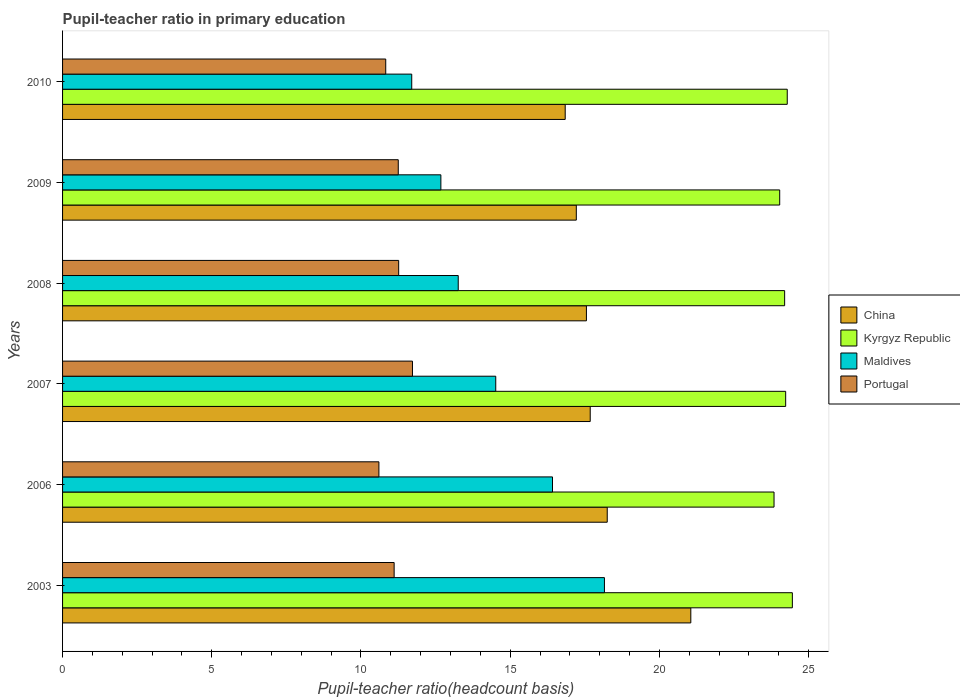How many different coloured bars are there?
Make the answer very short. 4. How many groups of bars are there?
Make the answer very short. 6. Are the number of bars on each tick of the Y-axis equal?
Make the answer very short. Yes. How many bars are there on the 4th tick from the top?
Your answer should be very brief. 4. What is the label of the 1st group of bars from the top?
Offer a terse response. 2010. In how many cases, is the number of bars for a given year not equal to the number of legend labels?
Your response must be concise. 0. What is the pupil-teacher ratio in primary education in Maldives in 2009?
Ensure brevity in your answer.  12.68. Across all years, what is the maximum pupil-teacher ratio in primary education in Portugal?
Provide a succinct answer. 11.73. Across all years, what is the minimum pupil-teacher ratio in primary education in Maldives?
Your answer should be compact. 11.7. In which year was the pupil-teacher ratio in primary education in China maximum?
Provide a short and direct response. 2003. What is the total pupil-teacher ratio in primary education in Kyrgyz Republic in the graph?
Offer a terse response. 145.04. What is the difference between the pupil-teacher ratio in primary education in China in 2006 and that in 2008?
Your answer should be compact. 0.7. What is the difference between the pupil-teacher ratio in primary education in Kyrgyz Republic in 2009 and the pupil-teacher ratio in primary education in China in 2007?
Offer a terse response. 6.35. What is the average pupil-teacher ratio in primary education in Portugal per year?
Your response must be concise. 11.13. In the year 2003, what is the difference between the pupil-teacher ratio in primary education in China and pupil-teacher ratio in primary education in Maldives?
Make the answer very short. 2.89. In how many years, is the pupil-teacher ratio in primary education in Maldives greater than 14 ?
Your answer should be compact. 3. What is the ratio of the pupil-teacher ratio in primary education in Kyrgyz Republic in 2009 to that in 2010?
Your response must be concise. 0.99. Is the pupil-teacher ratio in primary education in China in 2009 less than that in 2010?
Your answer should be very brief. No. What is the difference between the highest and the second highest pupil-teacher ratio in primary education in China?
Provide a succinct answer. 2.8. What is the difference between the highest and the lowest pupil-teacher ratio in primary education in Portugal?
Offer a very short reply. 1.12. Is the sum of the pupil-teacher ratio in primary education in China in 2006 and 2010 greater than the maximum pupil-teacher ratio in primary education in Kyrgyz Republic across all years?
Your answer should be compact. Yes. Is it the case that in every year, the sum of the pupil-teacher ratio in primary education in Portugal and pupil-teacher ratio in primary education in Maldives is greater than the sum of pupil-teacher ratio in primary education in Kyrgyz Republic and pupil-teacher ratio in primary education in China?
Keep it short and to the point. No. What does the 4th bar from the top in 2003 represents?
Give a very brief answer. China. What does the 2nd bar from the bottom in 2007 represents?
Offer a terse response. Kyrgyz Republic. Is it the case that in every year, the sum of the pupil-teacher ratio in primary education in Portugal and pupil-teacher ratio in primary education in Kyrgyz Republic is greater than the pupil-teacher ratio in primary education in Maldives?
Offer a very short reply. Yes. How are the legend labels stacked?
Your answer should be compact. Vertical. What is the title of the graph?
Offer a very short reply. Pupil-teacher ratio in primary education. What is the label or title of the X-axis?
Offer a terse response. Pupil-teacher ratio(headcount basis). What is the Pupil-teacher ratio(headcount basis) in China in 2003?
Provide a succinct answer. 21.05. What is the Pupil-teacher ratio(headcount basis) in Kyrgyz Republic in 2003?
Provide a succinct answer. 24.46. What is the Pupil-teacher ratio(headcount basis) of Maldives in 2003?
Your answer should be compact. 18.16. What is the Pupil-teacher ratio(headcount basis) in Portugal in 2003?
Your answer should be very brief. 11.11. What is the Pupil-teacher ratio(headcount basis) of China in 2006?
Your answer should be very brief. 18.25. What is the Pupil-teacher ratio(headcount basis) of Kyrgyz Republic in 2006?
Keep it short and to the point. 23.84. What is the Pupil-teacher ratio(headcount basis) in Maldives in 2006?
Your response must be concise. 16.42. What is the Pupil-teacher ratio(headcount basis) of Portugal in 2006?
Offer a very short reply. 10.6. What is the Pupil-teacher ratio(headcount basis) of China in 2007?
Your response must be concise. 17.68. What is the Pupil-teacher ratio(headcount basis) in Kyrgyz Republic in 2007?
Keep it short and to the point. 24.23. What is the Pupil-teacher ratio(headcount basis) of Maldives in 2007?
Your answer should be compact. 14.52. What is the Pupil-teacher ratio(headcount basis) of Portugal in 2007?
Offer a very short reply. 11.73. What is the Pupil-teacher ratio(headcount basis) of China in 2008?
Offer a very short reply. 17.55. What is the Pupil-teacher ratio(headcount basis) in Kyrgyz Republic in 2008?
Provide a short and direct response. 24.2. What is the Pupil-teacher ratio(headcount basis) of Maldives in 2008?
Your answer should be compact. 13.26. What is the Pupil-teacher ratio(headcount basis) in Portugal in 2008?
Keep it short and to the point. 11.26. What is the Pupil-teacher ratio(headcount basis) in China in 2009?
Keep it short and to the point. 17.22. What is the Pupil-teacher ratio(headcount basis) of Kyrgyz Republic in 2009?
Make the answer very short. 24.03. What is the Pupil-teacher ratio(headcount basis) of Maldives in 2009?
Ensure brevity in your answer.  12.68. What is the Pupil-teacher ratio(headcount basis) in Portugal in 2009?
Offer a very short reply. 11.25. What is the Pupil-teacher ratio(headcount basis) in China in 2010?
Your response must be concise. 16.84. What is the Pupil-teacher ratio(headcount basis) in Kyrgyz Republic in 2010?
Provide a short and direct response. 24.28. What is the Pupil-teacher ratio(headcount basis) of Maldives in 2010?
Your response must be concise. 11.7. What is the Pupil-teacher ratio(headcount basis) in Portugal in 2010?
Offer a terse response. 10.83. Across all years, what is the maximum Pupil-teacher ratio(headcount basis) of China?
Provide a short and direct response. 21.05. Across all years, what is the maximum Pupil-teacher ratio(headcount basis) of Kyrgyz Republic?
Keep it short and to the point. 24.46. Across all years, what is the maximum Pupil-teacher ratio(headcount basis) of Maldives?
Your response must be concise. 18.16. Across all years, what is the maximum Pupil-teacher ratio(headcount basis) in Portugal?
Your answer should be compact. 11.73. Across all years, what is the minimum Pupil-teacher ratio(headcount basis) of China?
Keep it short and to the point. 16.84. Across all years, what is the minimum Pupil-teacher ratio(headcount basis) of Kyrgyz Republic?
Provide a succinct answer. 23.84. Across all years, what is the minimum Pupil-teacher ratio(headcount basis) in Maldives?
Make the answer very short. 11.7. Across all years, what is the minimum Pupil-teacher ratio(headcount basis) in Portugal?
Provide a short and direct response. 10.6. What is the total Pupil-teacher ratio(headcount basis) in China in the graph?
Offer a very short reply. 108.6. What is the total Pupil-teacher ratio(headcount basis) in Kyrgyz Republic in the graph?
Make the answer very short. 145.04. What is the total Pupil-teacher ratio(headcount basis) of Maldives in the graph?
Offer a terse response. 86.73. What is the total Pupil-teacher ratio(headcount basis) of Portugal in the graph?
Your answer should be very brief. 66.78. What is the difference between the Pupil-teacher ratio(headcount basis) of China in 2003 and that in 2006?
Your answer should be very brief. 2.8. What is the difference between the Pupil-teacher ratio(headcount basis) in Kyrgyz Republic in 2003 and that in 2006?
Your answer should be very brief. 0.61. What is the difference between the Pupil-teacher ratio(headcount basis) of Maldives in 2003 and that in 2006?
Make the answer very short. 1.74. What is the difference between the Pupil-teacher ratio(headcount basis) in Portugal in 2003 and that in 2006?
Make the answer very short. 0.51. What is the difference between the Pupil-teacher ratio(headcount basis) in China in 2003 and that in 2007?
Keep it short and to the point. 3.37. What is the difference between the Pupil-teacher ratio(headcount basis) of Kyrgyz Republic in 2003 and that in 2007?
Provide a succinct answer. 0.22. What is the difference between the Pupil-teacher ratio(headcount basis) in Maldives in 2003 and that in 2007?
Offer a very short reply. 3.64. What is the difference between the Pupil-teacher ratio(headcount basis) in Portugal in 2003 and that in 2007?
Make the answer very short. -0.61. What is the difference between the Pupil-teacher ratio(headcount basis) of China in 2003 and that in 2008?
Your answer should be compact. 3.5. What is the difference between the Pupil-teacher ratio(headcount basis) of Kyrgyz Republic in 2003 and that in 2008?
Provide a succinct answer. 0.26. What is the difference between the Pupil-teacher ratio(headcount basis) of Maldives in 2003 and that in 2008?
Your response must be concise. 4.9. What is the difference between the Pupil-teacher ratio(headcount basis) of Portugal in 2003 and that in 2008?
Give a very brief answer. -0.15. What is the difference between the Pupil-teacher ratio(headcount basis) in China in 2003 and that in 2009?
Your answer should be very brief. 3.84. What is the difference between the Pupil-teacher ratio(headcount basis) in Kyrgyz Republic in 2003 and that in 2009?
Your answer should be compact. 0.42. What is the difference between the Pupil-teacher ratio(headcount basis) of Maldives in 2003 and that in 2009?
Provide a succinct answer. 5.48. What is the difference between the Pupil-teacher ratio(headcount basis) in Portugal in 2003 and that in 2009?
Give a very brief answer. -0.14. What is the difference between the Pupil-teacher ratio(headcount basis) of China in 2003 and that in 2010?
Your answer should be compact. 4.21. What is the difference between the Pupil-teacher ratio(headcount basis) of Kyrgyz Republic in 2003 and that in 2010?
Your answer should be very brief. 0.17. What is the difference between the Pupil-teacher ratio(headcount basis) in Maldives in 2003 and that in 2010?
Ensure brevity in your answer.  6.46. What is the difference between the Pupil-teacher ratio(headcount basis) of Portugal in 2003 and that in 2010?
Give a very brief answer. 0.28. What is the difference between the Pupil-teacher ratio(headcount basis) of China in 2006 and that in 2007?
Offer a very short reply. 0.57. What is the difference between the Pupil-teacher ratio(headcount basis) in Kyrgyz Republic in 2006 and that in 2007?
Give a very brief answer. -0.39. What is the difference between the Pupil-teacher ratio(headcount basis) in Maldives in 2006 and that in 2007?
Provide a short and direct response. 1.9. What is the difference between the Pupil-teacher ratio(headcount basis) of Portugal in 2006 and that in 2007?
Your answer should be compact. -1.12. What is the difference between the Pupil-teacher ratio(headcount basis) of China in 2006 and that in 2008?
Offer a very short reply. 0.7. What is the difference between the Pupil-teacher ratio(headcount basis) in Kyrgyz Republic in 2006 and that in 2008?
Offer a terse response. -0.36. What is the difference between the Pupil-teacher ratio(headcount basis) in Maldives in 2006 and that in 2008?
Your response must be concise. 3.16. What is the difference between the Pupil-teacher ratio(headcount basis) of Portugal in 2006 and that in 2008?
Ensure brevity in your answer.  -0.66. What is the difference between the Pupil-teacher ratio(headcount basis) of China in 2006 and that in 2009?
Your answer should be compact. 1.04. What is the difference between the Pupil-teacher ratio(headcount basis) of Kyrgyz Republic in 2006 and that in 2009?
Provide a succinct answer. -0.19. What is the difference between the Pupil-teacher ratio(headcount basis) of Maldives in 2006 and that in 2009?
Give a very brief answer. 3.74. What is the difference between the Pupil-teacher ratio(headcount basis) of Portugal in 2006 and that in 2009?
Offer a terse response. -0.65. What is the difference between the Pupil-teacher ratio(headcount basis) in China in 2006 and that in 2010?
Your response must be concise. 1.41. What is the difference between the Pupil-teacher ratio(headcount basis) in Kyrgyz Republic in 2006 and that in 2010?
Keep it short and to the point. -0.44. What is the difference between the Pupil-teacher ratio(headcount basis) of Maldives in 2006 and that in 2010?
Offer a terse response. 4.72. What is the difference between the Pupil-teacher ratio(headcount basis) in Portugal in 2006 and that in 2010?
Your response must be concise. -0.23. What is the difference between the Pupil-teacher ratio(headcount basis) in China in 2007 and that in 2008?
Keep it short and to the point. 0.13. What is the difference between the Pupil-teacher ratio(headcount basis) in Kyrgyz Republic in 2007 and that in 2008?
Your answer should be compact. 0.03. What is the difference between the Pupil-teacher ratio(headcount basis) in Maldives in 2007 and that in 2008?
Provide a short and direct response. 1.26. What is the difference between the Pupil-teacher ratio(headcount basis) in Portugal in 2007 and that in 2008?
Make the answer very short. 0.46. What is the difference between the Pupil-teacher ratio(headcount basis) of China in 2007 and that in 2009?
Your response must be concise. 0.47. What is the difference between the Pupil-teacher ratio(headcount basis) in Kyrgyz Republic in 2007 and that in 2009?
Your answer should be compact. 0.2. What is the difference between the Pupil-teacher ratio(headcount basis) in Maldives in 2007 and that in 2009?
Your answer should be very brief. 1.84. What is the difference between the Pupil-teacher ratio(headcount basis) in Portugal in 2007 and that in 2009?
Keep it short and to the point. 0.48. What is the difference between the Pupil-teacher ratio(headcount basis) in China in 2007 and that in 2010?
Provide a short and direct response. 0.84. What is the difference between the Pupil-teacher ratio(headcount basis) in Kyrgyz Republic in 2007 and that in 2010?
Keep it short and to the point. -0.05. What is the difference between the Pupil-teacher ratio(headcount basis) in Maldives in 2007 and that in 2010?
Provide a short and direct response. 2.82. What is the difference between the Pupil-teacher ratio(headcount basis) of Portugal in 2007 and that in 2010?
Ensure brevity in your answer.  0.9. What is the difference between the Pupil-teacher ratio(headcount basis) in China in 2008 and that in 2009?
Ensure brevity in your answer.  0.34. What is the difference between the Pupil-teacher ratio(headcount basis) in Kyrgyz Republic in 2008 and that in 2009?
Provide a succinct answer. 0.17. What is the difference between the Pupil-teacher ratio(headcount basis) in Maldives in 2008 and that in 2009?
Provide a short and direct response. 0.58. What is the difference between the Pupil-teacher ratio(headcount basis) in Portugal in 2008 and that in 2009?
Your response must be concise. 0.01. What is the difference between the Pupil-teacher ratio(headcount basis) of China in 2008 and that in 2010?
Give a very brief answer. 0.71. What is the difference between the Pupil-teacher ratio(headcount basis) of Kyrgyz Republic in 2008 and that in 2010?
Your response must be concise. -0.09. What is the difference between the Pupil-teacher ratio(headcount basis) of Maldives in 2008 and that in 2010?
Your answer should be very brief. 1.56. What is the difference between the Pupil-teacher ratio(headcount basis) of Portugal in 2008 and that in 2010?
Offer a terse response. 0.43. What is the difference between the Pupil-teacher ratio(headcount basis) of China in 2009 and that in 2010?
Your answer should be very brief. 0.37. What is the difference between the Pupil-teacher ratio(headcount basis) in Kyrgyz Republic in 2009 and that in 2010?
Give a very brief answer. -0.25. What is the difference between the Pupil-teacher ratio(headcount basis) in Maldives in 2009 and that in 2010?
Offer a very short reply. 0.98. What is the difference between the Pupil-teacher ratio(headcount basis) in Portugal in 2009 and that in 2010?
Offer a terse response. 0.42. What is the difference between the Pupil-teacher ratio(headcount basis) in China in 2003 and the Pupil-teacher ratio(headcount basis) in Kyrgyz Republic in 2006?
Provide a succinct answer. -2.79. What is the difference between the Pupil-teacher ratio(headcount basis) in China in 2003 and the Pupil-teacher ratio(headcount basis) in Maldives in 2006?
Provide a succinct answer. 4.64. What is the difference between the Pupil-teacher ratio(headcount basis) of China in 2003 and the Pupil-teacher ratio(headcount basis) of Portugal in 2006?
Provide a succinct answer. 10.45. What is the difference between the Pupil-teacher ratio(headcount basis) of Kyrgyz Republic in 2003 and the Pupil-teacher ratio(headcount basis) of Maldives in 2006?
Give a very brief answer. 8.04. What is the difference between the Pupil-teacher ratio(headcount basis) in Kyrgyz Republic in 2003 and the Pupil-teacher ratio(headcount basis) in Portugal in 2006?
Keep it short and to the point. 13.85. What is the difference between the Pupil-teacher ratio(headcount basis) of Maldives in 2003 and the Pupil-teacher ratio(headcount basis) of Portugal in 2006?
Ensure brevity in your answer.  7.56. What is the difference between the Pupil-teacher ratio(headcount basis) of China in 2003 and the Pupil-teacher ratio(headcount basis) of Kyrgyz Republic in 2007?
Provide a succinct answer. -3.18. What is the difference between the Pupil-teacher ratio(headcount basis) in China in 2003 and the Pupil-teacher ratio(headcount basis) in Maldives in 2007?
Keep it short and to the point. 6.54. What is the difference between the Pupil-teacher ratio(headcount basis) of China in 2003 and the Pupil-teacher ratio(headcount basis) of Portugal in 2007?
Give a very brief answer. 9.33. What is the difference between the Pupil-teacher ratio(headcount basis) of Kyrgyz Republic in 2003 and the Pupil-teacher ratio(headcount basis) of Maldives in 2007?
Provide a succinct answer. 9.94. What is the difference between the Pupil-teacher ratio(headcount basis) of Kyrgyz Republic in 2003 and the Pupil-teacher ratio(headcount basis) of Portugal in 2007?
Give a very brief answer. 12.73. What is the difference between the Pupil-teacher ratio(headcount basis) in Maldives in 2003 and the Pupil-teacher ratio(headcount basis) in Portugal in 2007?
Give a very brief answer. 6.43. What is the difference between the Pupil-teacher ratio(headcount basis) of China in 2003 and the Pupil-teacher ratio(headcount basis) of Kyrgyz Republic in 2008?
Provide a succinct answer. -3.14. What is the difference between the Pupil-teacher ratio(headcount basis) of China in 2003 and the Pupil-teacher ratio(headcount basis) of Maldives in 2008?
Offer a terse response. 7.79. What is the difference between the Pupil-teacher ratio(headcount basis) in China in 2003 and the Pupil-teacher ratio(headcount basis) in Portugal in 2008?
Offer a very short reply. 9.79. What is the difference between the Pupil-teacher ratio(headcount basis) of Kyrgyz Republic in 2003 and the Pupil-teacher ratio(headcount basis) of Maldives in 2008?
Offer a very short reply. 11.2. What is the difference between the Pupil-teacher ratio(headcount basis) of Kyrgyz Republic in 2003 and the Pupil-teacher ratio(headcount basis) of Portugal in 2008?
Give a very brief answer. 13.19. What is the difference between the Pupil-teacher ratio(headcount basis) of Maldives in 2003 and the Pupil-teacher ratio(headcount basis) of Portugal in 2008?
Offer a very short reply. 6.9. What is the difference between the Pupil-teacher ratio(headcount basis) in China in 2003 and the Pupil-teacher ratio(headcount basis) in Kyrgyz Republic in 2009?
Provide a succinct answer. -2.98. What is the difference between the Pupil-teacher ratio(headcount basis) of China in 2003 and the Pupil-teacher ratio(headcount basis) of Maldives in 2009?
Your answer should be compact. 8.38. What is the difference between the Pupil-teacher ratio(headcount basis) of China in 2003 and the Pupil-teacher ratio(headcount basis) of Portugal in 2009?
Provide a succinct answer. 9.8. What is the difference between the Pupil-teacher ratio(headcount basis) of Kyrgyz Republic in 2003 and the Pupil-teacher ratio(headcount basis) of Maldives in 2009?
Your answer should be compact. 11.78. What is the difference between the Pupil-teacher ratio(headcount basis) of Kyrgyz Republic in 2003 and the Pupil-teacher ratio(headcount basis) of Portugal in 2009?
Give a very brief answer. 13.21. What is the difference between the Pupil-teacher ratio(headcount basis) in Maldives in 2003 and the Pupil-teacher ratio(headcount basis) in Portugal in 2009?
Make the answer very short. 6.91. What is the difference between the Pupil-teacher ratio(headcount basis) in China in 2003 and the Pupil-teacher ratio(headcount basis) in Kyrgyz Republic in 2010?
Keep it short and to the point. -3.23. What is the difference between the Pupil-teacher ratio(headcount basis) in China in 2003 and the Pupil-teacher ratio(headcount basis) in Maldives in 2010?
Provide a succinct answer. 9.35. What is the difference between the Pupil-teacher ratio(headcount basis) of China in 2003 and the Pupil-teacher ratio(headcount basis) of Portugal in 2010?
Provide a succinct answer. 10.22. What is the difference between the Pupil-teacher ratio(headcount basis) in Kyrgyz Republic in 2003 and the Pupil-teacher ratio(headcount basis) in Maldives in 2010?
Offer a very short reply. 12.76. What is the difference between the Pupil-teacher ratio(headcount basis) of Kyrgyz Republic in 2003 and the Pupil-teacher ratio(headcount basis) of Portugal in 2010?
Your answer should be compact. 13.63. What is the difference between the Pupil-teacher ratio(headcount basis) in Maldives in 2003 and the Pupil-teacher ratio(headcount basis) in Portugal in 2010?
Provide a succinct answer. 7.33. What is the difference between the Pupil-teacher ratio(headcount basis) of China in 2006 and the Pupil-teacher ratio(headcount basis) of Kyrgyz Republic in 2007?
Provide a short and direct response. -5.98. What is the difference between the Pupil-teacher ratio(headcount basis) of China in 2006 and the Pupil-teacher ratio(headcount basis) of Maldives in 2007?
Ensure brevity in your answer.  3.74. What is the difference between the Pupil-teacher ratio(headcount basis) in China in 2006 and the Pupil-teacher ratio(headcount basis) in Portugal in 2007?
Your answer should be very brief. 6.53. What is the difference between the Pupil-teacher ratio(headcount basis) in Kyrgyz Republic in 2006 and the Pupil-teacher ratio(headcount basis) in Maldives in 2007?
Make the answer very short. 9.33. What is the difference between the Pupil-teacher ratio(headcount basis) in Kyrgyz Republic in 2006 and the Pupil-teacher ratio(headcount basis) in Portugal in 2007?
Make the answer very short. 12.12. What is the difference between the Pupil-teacher ratio(headcount basis) in Maldives in 2006 and the Pupil-teacher ratio(headcount basis) in Portugal in 2007?
Your answer should be very brief. 4.69. What is the difference between the Pupil-teacher ratio(headcount basis) in China in 2006 and the Pupil-teacher ratio(headcount basis) in Kyrgyz Republic in 2008?
Provide a short and direct response. -5.95. What is the difference between the Pupil-teacher ratio(headcount basis) in China in 2006 and the Pupil-teacher ratio(headcount basis) in Maldives in 2008?
Your answer should be compact. 4.99. What is the difference between the Pupil-teacher ratio(headcount basis) of China in 2006 and the Pupil-teacher ratio(headcount basis) of Portugal in 2008?
Your response must be concise. 6.99. What is the difference between the Pupil-teacher ratio(headcount basis) in Kyrgyz Republic in 2006 and the Pupil-teacher ratio(headcount basis) in Maldives in 2008?
Give a very brief answer. 10.58. What is the difference between the Pupil-teacher ratio(headcount basis) in Kyrgyz Republic in 2006 and the Pupil-teacher ratio(headcount basis) in Portugal in 2008?
Provide a short and direct response. 12.58. What is the difference between the Pupil-teacher ratio(headcount basis) in Maldives in 2006 and the Pupil-teacher ratio(headcount basis) in Portugal in 2008?
Keep it short and to the point. 5.15. What is the difference between the Pupil-teacher ratio(headcount basis) in China in 2006 and the Pupil-teacher ratio(headcount basis) in Kyrgyz Republic in 2009?
Make the answer very short. -5.78. What is the difference between the Pupil-teacher ratio(headcount basis) in China in 2006 and the Pupil-teacher ratio(headcount basis) in Maldives in 2009?
Your answer should be very brief. 5.57. What is the difference between the Pupil-teacher ratio(headcount basis) of China in 2006 and the Pupil-teacher ratio(headcount basis) of Portugal in 2009?
Offer a very short reply. 7. What is the difference between the Pupil-teacher ratio(headcount basis) of Kyrgyz Republic in 2006 and the Pupil-teacher ratio(headcount basis) of Maldives in 2009?
Give a very brief answer. 11.16. What is the difference between the Pupil-teacher ratio(headcount basis) of Kyrgyz Republic in 2006 and the Pupil-teacher ratio(headcount basis) of Portugal in 2009?
Your answer should be very brief. 12.59. What is the difference between the Pupil-teacher ratio(headcount basis) of Maldives in 2006 and the Pupil-teacher ratio(headcount basis) of Portugal in 2009?
Your response must be concise. 5.17. What is the difference between the Pupil-teacher ratio(headcount basis) in China in 2006 and the Pupil-teacher ratio(headcount basis) in Kyrgyz Republic in 2010?
Offer a very short reply. -6.03. What is the difference between the Pupil-teacher ratio(headcount basis) of China in 2006 and the Pupil-teacher ratio(headcount basis) of Maldives in 2010?
Your answer should be very brief. 6.55. What is the difference between the Pupil-teacher ratio(headcount basis) in China in 2006 and the Pupil-teacher ratio(headcount basis) in Portugal in 2010?
Make the answer very short. 7.42. What is the difference between the Pupil-teacher ratio(headcount basis) in Kyrgyz Republic in 2006 and the Pupil-teacher ratio(headcount basis) in Maldives in 2010?
Give a very brief answer. 12.14. What is the difference between the Pupil-teacher ratio(headcount basis) of Kyrgyz Republic in 2006 and the Pupil-teacher ratio(headcount basis) of Portugal in 2010?
Your answer should be compact. 13.01. What is the difference between the Pupil-teacher ratio(headcount basis) in Maldives in 2006 and the Pupil-teacher ratio(headcount basis) in Portugal in 2010?
Offer a terse response. 5.59. What is the difference between the Pupil-teacher ratio(headcount basis) in China in 2007 and the Pupil-teacher ratio(headcount basis) in Kyrgyz Republic in 2008?
Make the answer very short. -6.52. What is the difference between the Pupil-teacher ratio(headcount basis) in China in 2007 and the Pupil-teacher ratio(headcount basis) in Maldives in 2008?
Give a very brief answer. 4.42. What is the difference between the Pupil-teacher ratio(headcount basis) in China in 2007 and the Pupil-teacher ratio(headcount basis) in Portugal in 2008?
Make the answer very short. 6.42. What is the difference between the Pupil-teacher ratio(headcount basis) of Kyrgyz Republic in 2007 and the Pupil-teacher ratio(headcount basis) of Maldives in 2008?
Offer a very short reply. 10.97. What is the difference between the Pupil-teacher ratio(headcount basis) of Kyrgyz Republic in 2007 and the Pupil-teacher ratio(headcount basis) of Portugal in 2008?
Offer a very short reply. 12.97. What is the difference between the Pupil-teacher ratio(headcount basis) in Maldives in 2007 and the Pupil-teacher ratio(headcount basis) in Portugal in 2008?
Your response must be concise. 3.25. What is the difference between the Pupil-teacher ratio(headcount basis) in China in 2007 and the Pupil-teacher ratio(headcount basis) in Kyrgyz Republic in 2009?
Provide a short and direct response. -6.35. What is the difference between the Pupil-teacher ratio(headcount basis) of China in 2007 and the Pupil-teacher ratio(headcount basis) of Maldives in 2009?
Your answer should be compact. 5. What is the difference between the Pupil-teacher ratio(headcount basis) in China in 2007 and the Pupil-teacher ratio(headcount basis) in Portugal in 2009?
Provide a short and direct response. 6.43. What is the difference between the Pupil-teacher ratio(headcount basis) of Kyrgyz Republic in 2007 and the Pupil-teacher ratio(headcount basis) of Maldives in 2009?
Your response must be concise. 11.55. What is the difference between the Pupil-teacher ratio(headcount basis) in Kyrgyz Republic in 2007 and the Pupil-teacher ratio(headcount basis) in Portugal in 2009?
Your response must be concise. 12.98. What is the difference between the Pupil-teacher ratio(headcount basis) of Maldives in 2007 and the Pupil-teacher ratio(headcount basis) of Portugal in 2009?
Offer a very short reply. 3.27. What is the difference between the Pupil-teacher ratio(headcount basis) of China in 2007 and the Pupil-teacher ratio(headcount basis) of Kyrgyz Republic in 2010?
Your response must be concise. -6.6. What is the difference between the Pupil-teacher ratio(headcount basis) in China in 2007 and the Pupil-teacher ratio(headcount basis) in Maldives in 2010?
Provide a succinct answer. 5.98. What is the difference between the Pupil-teacher ratio(headcount basis) in China in 2007 and the Pupil-teacher ratio(headcount basis) in Portugal in 2010?
Offer a terse response. 6.85. What is the difference between the Pupil-teacher ratio(headcount basis) in Kyrgyz Republic in 2007 and the Pupil-teacher ratio(headcount basis) in Maldives in 2010?
Provide a short and direct response. 12.53. What is the difference between the Pupil-teacher ratio(headcount basis) of Kyrgyz Republic in 2007 and the Pupil-teacher ratio(headcount basis) of Portugal in 2010?
Keep it short and to the point. 13.4. What is the difference between the Pupil-teacher ratio(headcount basis) of Maldives in 2007 and the Pupil-teacher ratio(headcount basis) of Portugal in 2010?
Your answer should be very brief. 3.69. What is the difference between the Pupil-teacher ratio(headcount basis) of China in 2008 and the Pupil-teacher ratio(headcount basis) of Kyrgyz Republic in 2009?
Your answer should be compact. -6.48. What is the difference between the Pupil-teacher ratio(headcount basis) of China in 2008 and the Pupil-teacher ratio(headcount basis) of Maldives in 2009?
Offer a terse response. 4.88. What is the difference between the Pupil-teacher ratio(headcount basis) of China in 2008 and the Pupil-teacher ratio(headcount basis) of Portugal in 2009?
Ensure brevity in your answer.  6.3. What is the difference between the Pupil-teacher ratio(headcount basis) in Kyrgyz Republic in 2008 and the Pupil-teacher ratio(headcount basis) in Maldives in 2009?
Give a very brief answer. 11.52. What is the difference between the Pupil-teacher ratio(headcount basis) of Kyrgyz Republic in 2008 and the Pupil-teacher ratio(headcount basis) of Portugal in 2009?
Your answer should be compact. 12.95. What is the difference between the Pupil-teacher ratio(headcount basis) in Maldives in 2008 and the Pupil-teacher ratio(headcount basis) in Portugal in 2009?
Ensure brevity in your answer.  2.01. What is the difference between the Pupil-teacher ratio(headcount basis) in China in 2008 and the Pupil-teacher ratio(headcount basis) in Kyrgyz Republic in 2010?
Offer a very short reply. -6.73. What is the difference between the Pupil-teacher ratio(headcount basis) in China in 2008 and the Pupil-teacher ratio(headcount basis) in Maldives in 2010?
Make the answer very short. 5.85. What is the difference between the Pupil-teacher ratio(headcount basis) of China in 2008 and the Pupil-teacher ratio(headcount basis) of Portugal in 2010?
Ensure brevity in your answer.  6.73. What is the difference between the Pupil-teacher ratio(headcount basis) in Kyrgyz Republic in 2008 and the Pupil-teacher ratio(headcount basis) in Maldives in 2010?
Keep it short and to the point. 12.5. What is the difference between the Pupil-teacher ratio(headcount basis) of Kyrgyz Republic in 2008 and the Pupil-teacher ratio(headcount basis) of Portugal in 2010?
Your response must be concise. 13.37. What is the difference between the Pupil-teacher ratio(headcount basis) in Maldives in 2008 and the Pupil-teacher ratio(headcount basis) in Portugal in 2010?
Offer a very short reply. 2.43. What is the difference between the Pupil-teacher ratio(headcount basis) in China in 2009 and the Pupil-teacher ratio(headcount basis) in Kyrgyz Republic in 2010?
Your answer should be compact. -7.07. What is the difference between the Pupil-teacher ratio(headcount basis) in China in 2009 and the Pupil-teacher ratio(headcount basis) in Maldives in 2010?
Your answer should be very brief. 5.51. What is the difference between the Pupil-teacher ratio(headcount basis) in China in 2009 and the Pupil-teacher ratio(headcount basis) in Portugal in 2010?
Give a very brief answer. 6.39. What is the difference between the Pupil-teacher ratio(headcount basis) of Kyrgyz Republic in 2009 and the Pupil-teacher ratio(headcount basis) of Maldives in 2010?
Make the answer very short. 12.33. What is the difference between the Pupil-teacher ratio(headcount basis) in Kyrgyz Republic in 2009 and the Pupil-teacher ratio(headcount basis) in Portugal in 2010?
Ensure brevity in your answer.  13.2. What is the difference between the Pupil-teacher ratio(headcount basis) in Maldives in 2009 and the Pupil-teacher ratio(headcount basis) in Portugal in 2010?
Ensure brevity in your answer.  1.85. What is the average Pupil-teacher ratio(headcount basis) of China per year?
Offer a very short reply. 18.1. What is the average Pupil-teacher ratio(headcount basis) in Kyrgyz Republic per year?
Provide a succinct answer. 24.17. What is the average Pupil-teacher ratio(headcount basis) in Maldives per year?
Provide a succinct answer. 14.45. What is the average Pupil-teacher ratio(headcount basis) of Portugal per year?
Offer a terse response. 11.13. In the year 2003, what is the difference between the Pupil-teacher ratio(headcount basis) in China and Pupil-teacher ratio(headcount basis) in Kyrgyz Republic?
Make the answer very short. -3.4. In the year 2003, what is the difference between the Pupil-teacher ratio(headcount basis) of China and Pupil-teacher ratio(headcount basis) of Maldives?
Ensure brevity in your answer.  2.89. In the year 2003, what is the difference between the Pupil-teacher ratio(headcount basis) of China and Pupil-teacher ratio(headcount basis) of Portugal?
Your answer should be very brief. 9.94. In the year 2003, what is the difference between the Pupil-teacher ratio(headcount basis) of Kyrgyz Republic and Pupil-teacher ratio(headcount basis) of Maldives?
Offer a very short reply. 6.3. In the year 2003, what is the difference between the Pupil-teacher ratio(headcount basis) of Kyrgyz Republic and Pupil-teacher ratio(headcount basis) of Portugal?
Your answer should be compact. 13.34. In the year 2003, what is the difference between the Pupil-teacher ratio(headcount basis) in Maldives and Pupil-teacher ratio(headcount basis) in Portugal?
Give a very brief answer. 7.05. In the year 2006, what is the difference between the Pupil-teacher ratio(headcount basis) of China and Pupil-teacher ratio(headcount basis) of Kyrgyz Republic?
Make the answer very short. -5.59. In the year 2006, what is the difference between the Pupil-teacher ratio(headcount basis) in China and Pupil-teacher ratio(headcount basis) in Maldives?
Offer a very short reply. 1.83. In the year 2006, what is the difference between the Pupil-teacher ratio(headcount basis) of China and Pupil-teacher ratio(headcount basis) of Portugal?
Your answer should be very brief. 7.65. In the year 2006, what is the difference between the Pupil-teacher ratio(headcount basis) in Kyrgyz Republic and Pupil-teacher ratio(headcount basis) in Maldives?
Make the answer very short. 7.42. In the year 2006, what is the difference between the Pupil-teacher ratio(headcount basis) in Kyrgyz Republic and Pupil-teacher ratio(headcount basis) in Portugal?
Offer a very short reply. 13.24. In the year 2006, what is the difference between the Pupil-teacher ratio(headcount basis) of Maldives and Pupil-teacher ratio(headcount basis) of Portugal?
Offer a very short reply. 5.82. In the year 2007, what is the difference between the Pupil-teacher ratio(headcount basis) in China and Pupil-teacher ratio(headcount basis) in Kyrgyz Republic?
Provide a succinct answer. -6.55. In the year 2007, what is the difference between the Pupil-teacher ratio(headcount basis) in China and Pupil-teacher ratio(headcount basis) in Maldives?
Provide a short and direct response. 3.17. In the year 2007, what is the difference between the Pupil-teacher ratio(headcount basis) of China and Pupil-teacher ratio(headcount basis) of Portugal?
Ensure brevity in your answer.  5.96. In the year 2007, what is the difference between the Pupil-teacher ratio(headcount basis) in Kyrgyz Republic and Pupil-teacher ratio(headcount basis) in Maldives?
Give a very brief answer. 9.72. In the year 2007, what is the difference between the Pupil-teacher ratio(headcount basis) in Kyrgyz Republic and Pupil-teacher ratio(headcount basis) in Portugal?
Offer a very short reply. 12.51. In the year 2007, what is the difference between the Pupil-teacher ratio(headcount basis) of Maldives and Pupil-teacher ratio(headcount basis) of Portugal?
Offer a very short reply. 2.79. In the year 2008, what is the difference between the Pupil-teacher ratio(headcount basis) of China and Pupil-teacher ratio(headcount basis) of Kyrgyz Republic?
Make the answer very short. -6.64. In the year 2008, what is the difference between the Pupil-teacher ratio(headcount basis) of China and Pupil-teacher ratio(headcount basis) of Maldives?
Your answer should be very brief. 4.3. In the year 2008, what is the difference between the Pupil-teacher ratio(headcount basis) of China and Pupil-teacher ratio(headcount basis) of Portugal?
Give a very brief answer. 6.29. In the year 2008, what is the difference between the Pupil-teacher ratio(headcount basis) in Kyrgyz Republic and Pupil-teacher ratio(headcount basis) in Maldives?
Your answer should be compact. 10.94. In the year 2008, what is the difference between the Pupil-teacher ratio(headcount basis) in Kyrgyz Republic and Pupil-teacher ratio(headcount basis) in Portugal?
Provide a short and direct response. 12.93. In the year 2008, what is the difference between the Pupil-teacher ratio(headcount basis) of Maldives and Pupil-teacher ratio(headcount basis) of Portugal?
Your response must be concise. 2. In the year 2009, what is the difference between the Pupil-teacher ratio(headcount basis) in China and Pupil-teacher ratio(headcount basis) in Kyrgyz Republic?
Offer a very short reply. -6.82. In the year 2009, what is the difference between the Pupil-teacher ratio(headcount basis) in China and Pupil-teacher ratio(headcount basis) in Maldives?
Keep it short and to the point. 4.54. In the year 2009, what is the difference between the Pupil-teacher ratio(headcount basis) in China and Pupil-teacher ratio(headcount basis) in Portugal?
Your answer should be compact. 5.97. In the year 2009, what is the difference between the Pupil-teacher ratio(headcount basis) of Kyrgyz Republic and Pupil-teacher ratio(headcount basis) of Maldives?
Your response must be concise. 11.35. In the year 2009, what is the difference between the Pupil-teacher ratio(headcount basis) of Kyrgyz Republic and Pupil-teacher ratio(headcount basis) of Portugal?
Provide a succinct answer. 12.78. In the year 2009, what is the difference between the Pupil-teacher ratio(headcount basis) of Maldives and Pupil-teacher ratio(headcount basis) of Portugal?
Make the answer very short. 1.43. In the year 2010, what is the difference between the Pupil-teacher ratio(headcount basis) of China and Pupil-teacher ratio(headcount basis) of Kyrgyz Republic?
Provide a succinct answer. -7.44. In the year 2010, what is the difference between the Pupil-teacher ratio(headcount basis) of China and Pupil-teacher ratio(headcount basis) of Maldives?
Provide a succinct answer. 5.14. In the year 2010, what is the difference between the Pupil-teacher ratio(headcount basis) in China and Pupil-teacher ratio(headcount basis) in Portugal?
Ensure brevity in your answer.  6.01. In the year 2010, what is the difference between the Pupil-teacher ratio(headcount basis) of Kyrgyz Republic and Pupil-teacher ratio(headcount basis) of Maldives?
Ensure brevity in your answer.  12.58. In the year 2010, what is the difference between the Pupil-teacher ratio(headcount basis) in Kyrgyz Republic and Pupil-teacher ratio(headcount basis) in Portugal?
Ensure brevity in your answer.  13.46. In the year 2010, what is the difference between the Pupil-teacher ratio(headcount basis) in Maldives and Pupil-teacher ratio(headcount basis) in Portugal?
Your response must be concise. 0.87. What is the ratio of the Pupil-teacher ratio(headcount basis) of China in 2003 to that in 2006?
Offer a very short reply. 1.15. What is the ratio of the Pupil-teacher ratio(headcount basis) in Kyrgyz Republic in 2003 to that in 2006?
Your response must be concise. 1.03. What is the ratio of the Pupil-teacher ratio(headcount basis) of Maldives in 2003 to that in 2006?
Provide a short and direct response. 1.11. What is the ratio of the Pupil-teacher ratio(headcount basis) of Portugal in 2003 to that in 2006?
Make the answer very short. 1.05. What is the ratio of the Pupil-teacher ratio(headcount basis) in China in 2003 to that in 2007?
Keep it short and to the point. 1.19. What is the ratio of the Pupil-teacher ratio(headcount basis) of Kyrgyz Republic in 2003 to that in 2007?
Make the answer very short. 1.01. What is the ratio of the Pupil-teacher ratio(headcount basis) of Maldives in 2003 to that in 2007?
Ensure brevity in your answer.  1.25. What is the ratio of the Pupil-teacher ratio(headcount basis) in Portugal in 2003 to that in 2007?
Offer a very short reply. 0.95. What is the ratio of the Pupil-teacher ratio(headcount basis) of China in 2003 to that in 2008?
Ensure brevity in your answer.  1.2. What is the ratio of the Pupil-teacher ratio(headcount basis) in Kyrgyz Republic in 2003 to that in 2008?
Ensure brevity in your answer.  1.01. What is the ratio of the Pupil-teacher ratio(headcount basis) in Maldives in 2003 to that in 2008?
Make the answer very short. 1.37. What is the ratio of the Pupil-teacher ratio(headcount basis) of Portugal in 2003 to that in 2008?
Ensure brevity in your answer.  0.99. What is the ratio of the Pupil-teacher ratio(headcount basis) in China in 2003 to that in 2009?
Ensure brevity in your answer.  1.22. What is the ratio of the Pupil-teacher ratio(headcount basis) of Kyrgyz Republic in 2003 to that in 2009?
Offer a very short reply. 1.02. What is the ratio of the Pupil-teacher ratio(headcount basis) of Maldives in 2003 to that in 2009?
Your response must be concise. 1.43. What is the ratio of the Pupil-teacher ratio(headcount basis) of Portugal in 2003 to that in 2009?
Your response must be concise. 0.99. What is the ratio of the Pupil-teacher ratio(headcount basis) in China in 2003 to that in 2010?
Offer a very short reply. 1.25. What is the ratio of the Pupil-teacher ratio(headcount basis) in Kyrgyz Republic in 2003 to that in 2010?
Make the answer very short. 1.01. What is the ratio of the Pupil-teacher ratio(headcount basis) in Maldives in 2003 to that in 2010?
Your answer should be very brief. 1.55. What is the ratio of the Pupil-teacher ratio(headcount basis) of Portugal in 2003 to that in 2010?
Offer a very short reply. 1.03. What is the ratio of the Pupil-teacher ratio(headcount basis) in China in 2006 to that in 2007?
Your answer should be compact. 1.03. What is the ratio of the Pupil-teacher ratio(headcount basis) in Kyrgyz Republic in 2006 to that in 2007?
Provide a succinct answer. 0.98. What is the ratio of the Pupil-teacher ratio(headcount basis) of Maldives in 2006 to that in 2007?
Your response must be concise. 1.13. What is the ratio of the Pupil-teacher ratio(headcount basis) of Portugal in 2006 to that in 2007?
Give a very brief answer. 0.9. What is the ratio of the Pupil-teacher ratio(headcount basis) of China in 2006 to that in 2008?
Your response must be concise. 1.04. What is the ratio of the Pupil-teacher ratio(headcount basis) in Kyrgyz Republic in 2006 to that in 2008?
Ensure brevity in your answer.  0.99. What is the ratio of the Pupil-teacher ratio(headcount basis) in Maldives in 2006 to that in 2008?
Provide a short and direct response. 1.24. What is the ratio of the Pupil-teacher ratio(headcount basis) in Portugal in 2006 to that in 2008?
Your answer should be very brief. 0.94. What is the ratio of the Pupil-teacher ratio(headcount basis) of China in 2006 to that in 2009?
Make the answer very short. 1.06. What is the ratio of the Pupil-teacher ratio(headcount basis) of Kyrgyz Republic in 2006 to that in 2009?
Make the answer very short. 0.99. What is the ratio of the Pupil-teacher ratio(headcount basis) in Maldives in 2006 to that in 2009?
Ensure brevity in your answer.  1.3. What is the ratio of the Pupil-teacher ratio(headcount basis) in Portugal in 2006 to that in 2009?
Give a very brief answer. 0.94. What is the ratio of the Pupil-teacher ratio(headcount basis) in China in 2006 to that in 2010?
Give a very brief answer. 1.08. What is the ratio of the Pupil-teacher ratio(headcount basis) of Kyrgyz Republic in 2006 to that in 2010?
Give a very brief answer. 0.98. What is the ratio of the Pupil-teacher ratio(headcount basis) of Maldives in 2006 to that in 2010?
Your answer should be compact. 1.4. What is the ratio of the Pupil-teacher ratio(headcount basis) of Portugal in 2006 to that in 2010?
Offer a very short reply. 0.98. What is the ratio of the Pupil-teacher ratio(headcount basis) in China in 2007 to that in 2008?
Give a very brief answer. 1.01. What is the ratio of the Pupil-teacher ratio(headcount basis) of Maldives in 2007 to that in 2008?
Give a very brief answer. 1.09. What is the ratio of the Pupil-teacher ratio(headcount basis) in Portugal in 2007 to that in 2008?
Ensure brevity in your answer.  1.04. What is the ratio of the Pupil-teacher ratio(headcount basis) in China in 2007 to that in 2009?
Offer a very short reply. 1.03. What is the ratio of the Pupil-teacher ratio(headcount basis) in Kyrgyz Republic in 2007 to that in 2009?
Offer a very short reply. 1.01. What is the ratio of the Pupil-teacher ratio(headcount basis) in Maldives in 2007 to that in 2009?
Your answer should be very brief. 1.15. What is the ratio of the Pupil-teacher ratio(headcount basis) in Portugal in 2007 to that in 2009?
Your answer should be compact. 1.04. What is the ratio of the Pupil-teacher ratio(headcount basis) of China in 2007 to that in 2010?
Keep it short and to the point. 1.05. What is the ratio of the Pupil-teacher ratio(headcount basis) of Maldives in 2007 to that in 2010?
Your response must be concise. 1.24. What is the ratio of the Pupil-teacher ratio(headcount basis) in Portugal in 2007 to that in 2010?
Keep it short and to the point. 1.08. What is the ratio of the Pupil-teacher ratio(headcount basis) in China in 2008 to that in 2009?
Offer a terse response. 1.02. What is the ratio of the Pupil-teacher ratio(headcount basis) in Maldives in 2008 to that in 2009?
Your answer should be compact. 1.05. What is the ratio of the Pupil-teacher ratio(headcount basis) in Portugal in 2008 to that in 2009?
Keep it short and to the point. 1. What is the ratio of the Pupil-teacher ratio(headcount basis) in China in 2008 to that in 2010?
Offer a terse response. 1.04. What is the ratio of the Pupil-teacher ratio(headcount basis) in Kyrgyz Republic in 2008 to that in 2010?
Ensure brevity in your answer.  1. What is the ratio of the Pupil-teacher ratio(headcount basis) of Maldives in 2008 to that in 2010?
Your answer should be very brief. 1.13. What is the ratio of the Pupil-teacher ratio(headcount basis) of Portugal in 2008 to that in 2010?
Give a very brief answer. 1.04. What is the ratio of the Pupil-teacher ratio(headcount basis) in China in 2009 to that in 2010?
Make the answer very short. 1.02. What is the ratio of the Pupil-teacher ratio(headcount basis) of Kyrgyz Republic in 2009 to that in 2010?
Give a very brief answer. 0.99. What is the ratio of the Pupil-teacher ratio(headcount basis) in Maldives in 2009 to that in 2010?
Your answer should be very brief. 1.08. What is the ratio of the Pupil-teacher ratio(headcount basis) in Portugal in 2009 to that in 2010?
Offer a terse response. 1.04. What is the difference between the highest and the second highest Pupil-teacher ratio(headcount basis) in China?
Provide a succinct answer. 2.8. What is the difference between the highest and the second highest Pupil-teacher ratio(headcount basis) in Kyrgyz Republic?
Give a very brief answer. 0.17. What is the difference between the highest and the second highest Pupil-teacher ratio(headcount basis) in Maldives?
Your answer should be compact. 1.74. What is the difference between the highest and the second highest Pupil-teacher ratio(headcount basis) of Portugal?
Offer a terse response. 0.46. What is the difference between the highest and the lowest Pupil-teacher ratio(headcount basis) in China?
Offer a very short reply. 4.21. What is the difference between the highest and the lowest Pupil-teacher ratio(headcount basis) of Kyrgyz Republic?
Ensure brevity in your answer.  0.61. What is the difference between the highest and the lowest Pupil-teacher ratio(headcount basis) in Maldives?
Make the answer very short. 6.46. What is the difference between the highest and the lowest Pupil-teacher ratio(headcount basis) of Portugal?
Offer a terse response. 1.12. 